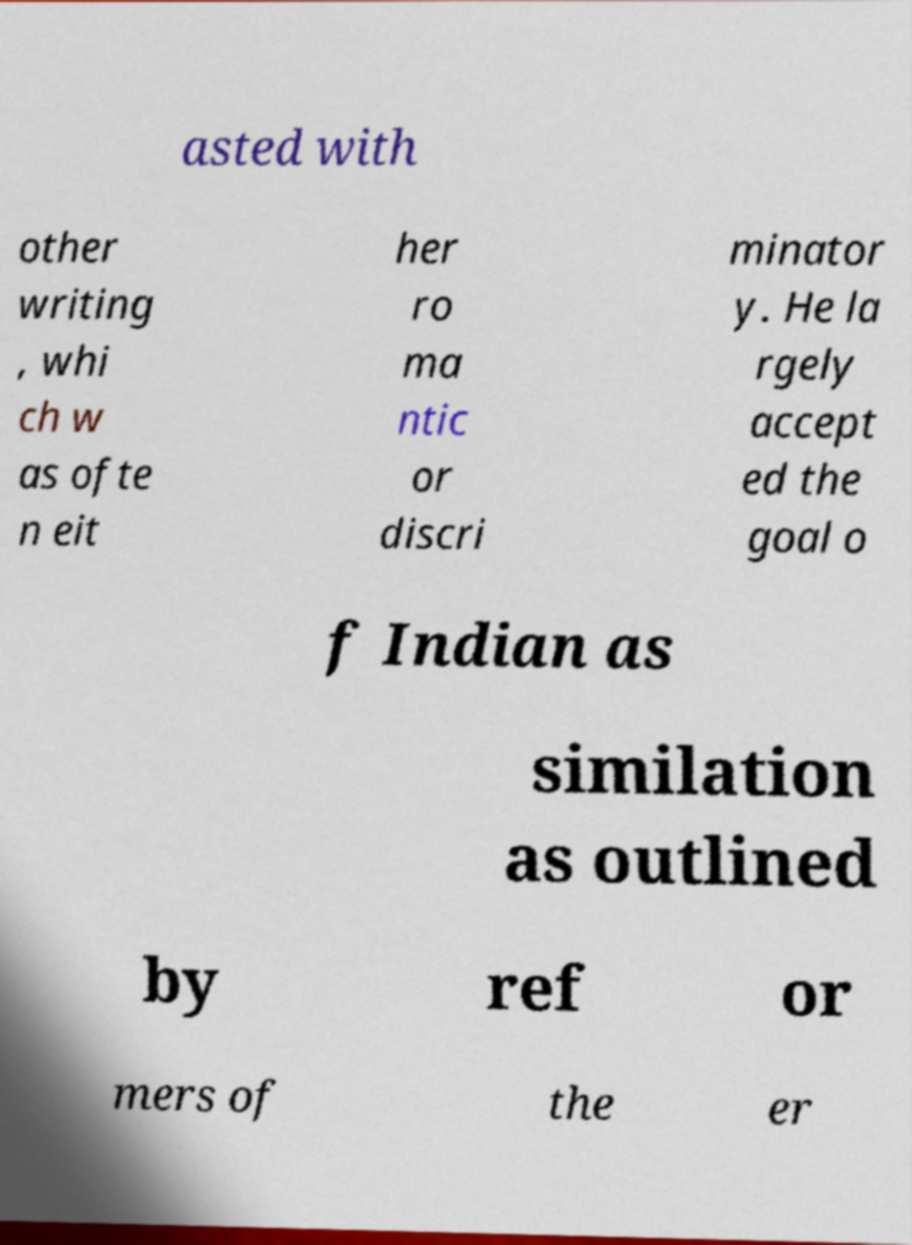Can you read and provide the text displayed in the image?This photo seems to have some interesting text. Can you extract and type it out for me? asted with other writing , whi ch w as ofte n eit her ro ma ntic or discri minator y. He la rgely accept ed the goal o f Indian as similation as outlined by ref or mers of the er 